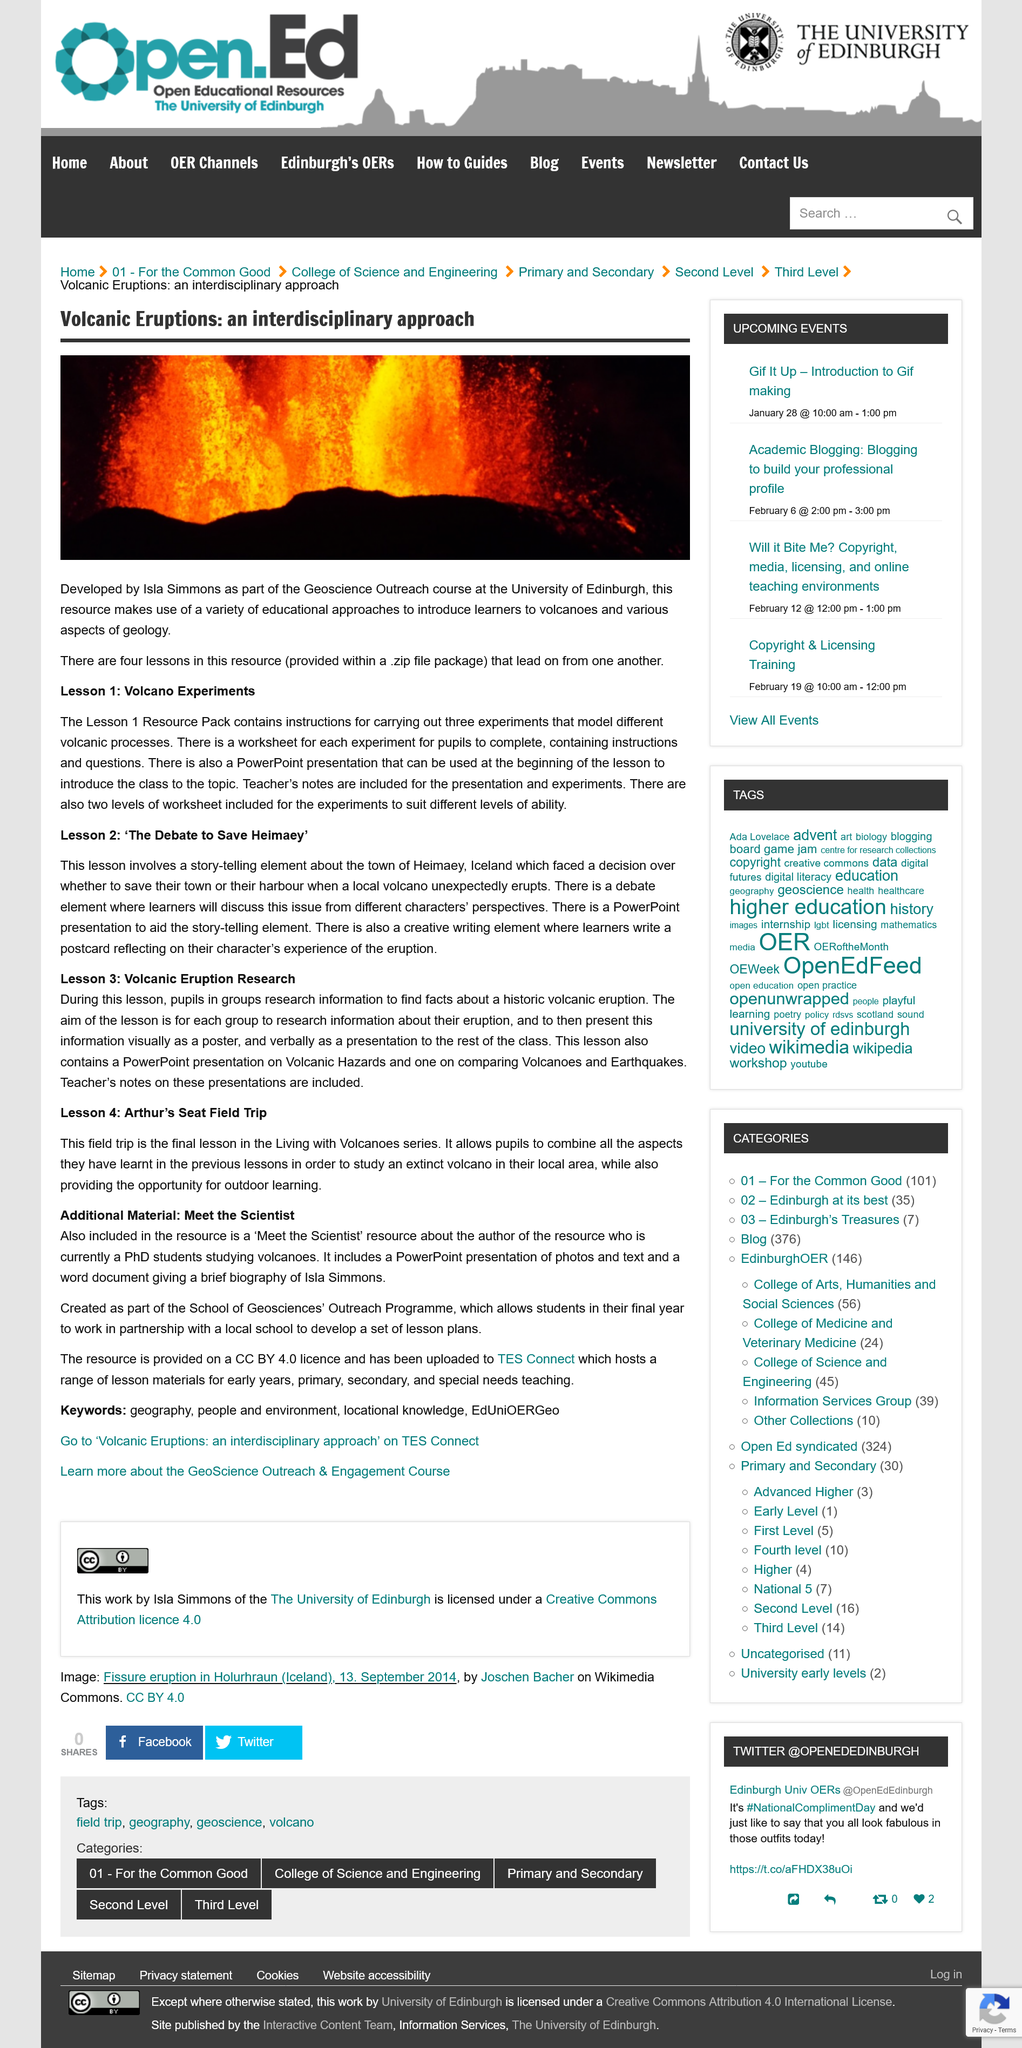List a handful of essential elements in this visual. The type of file that holds the four lessons is a .zip file. The town of Helmaey was faced with a difficult decision when an unexpected volcano eruption occurred. They had to decide whether to prioritize saving their town or their harbor. The University of Edinburgh played a crucial role in the development of the resource. In Lesson 2 of the creative-writing element, learners are required to write a postcard reflecting on their character's experience of the eruption. This lesson is part of the "Living with Volcanoes" series. 